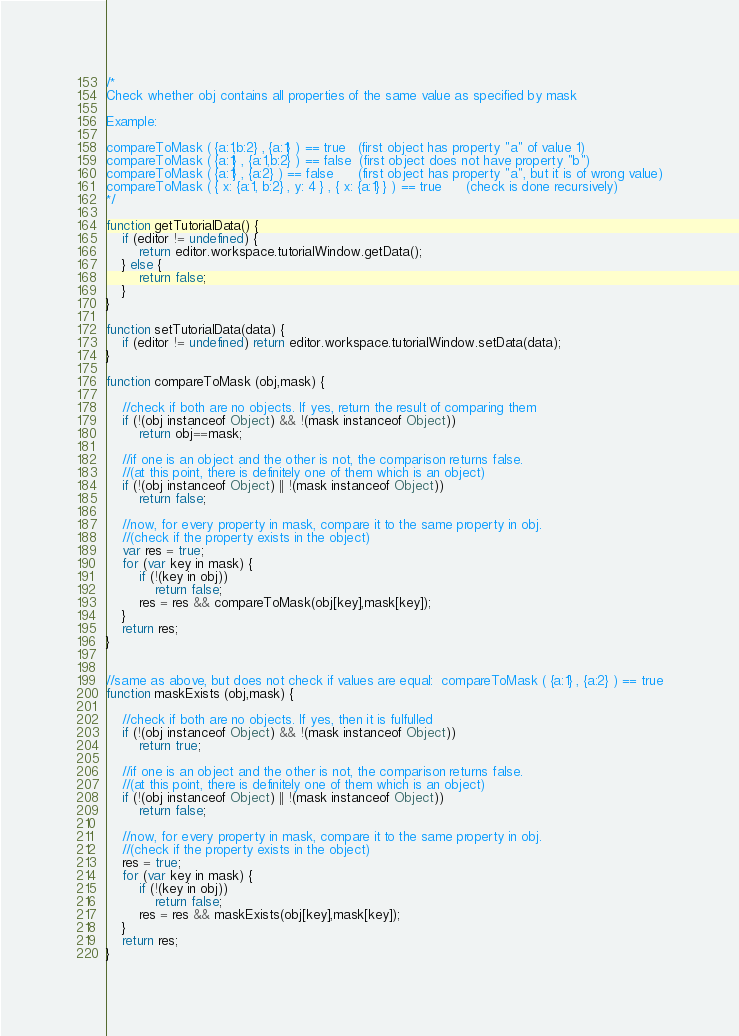<code> <loc_0><loc_0><loc_500><loc_500><_JavaScript_>/*
Check whether obj contains all properties of the same value as specified by mask

Example:

compareToMask ( {a:1,b:2} , {a:1} ) == true   (first object has property "a" of value 1)
compareToMask ( {a:1} , {a:1,b:2} ) == false  (first object does not have property "b") 
compareToMask ( {a:1} , {a:2} ) == false      (first object has property "a", but it is of wrong value)
compareToMask ( { x: {a:1, b:2} , y: 4 } , { x: {a:1} } ) == true      (check is done recursively)
*/

function getTutorialData() {
	if (editor != undefined) {
		return editor.workspace.tutorialWindow.getData();
	} else {
		return false;
	}
}

function setTutorialData(data) {
	if (editor != undefined) return editor.workspace.tutorialWindow.setData(data);
}

function compareToMask (obj,mask) {

	//check if both are no objects. If yes, return the result of comparing them
	if (!(obj instanceof Object) && !(mask instanceof Object))
		return obj==mask;
		
	//if one is an object and the other is not, the comparison returns false.
	//(at this point, there is definitely one of them which is an object)
	if (!(obj instanceof Object) || !(mask instanceof Object))
		return false;
	
	//now, for every property in mask, compare it to the same property in obj.
	//(check if the property exists in the object)
	var res = true;
	for (var key in mask) {
		if (!(key in obj))
			return false;
		res = res && compareToMask(obj[key],mask[key]);
    }
	return res;
}


//same as above, but does not check if values are equal:  compareToMask ( {a:1} , {a:2} ) == true
function maskExists (obj,mask) {

	//check if both are no objects. If yes, then it is fulfulled
	if (!(obj instanceof Object) && !(mask instanceof Object))
		return true;
		
	//if one is an object and the other is not, the comparison returns false.
	//(at this point, there is definitely one of them which is an object)
	if (!(obj instanceof Object) || !(mask instanceof Object))
		return false;
	
	//now, for every property in mask, compare it to the same property in obj.
	//(check if the property exists in the object)
	res = true;
	for (var key in mask) {
		if (!(key in obj))
			return false;
		res = res && maskExists(obj[key],mask[key]);
    }
	return res;
}</code> 